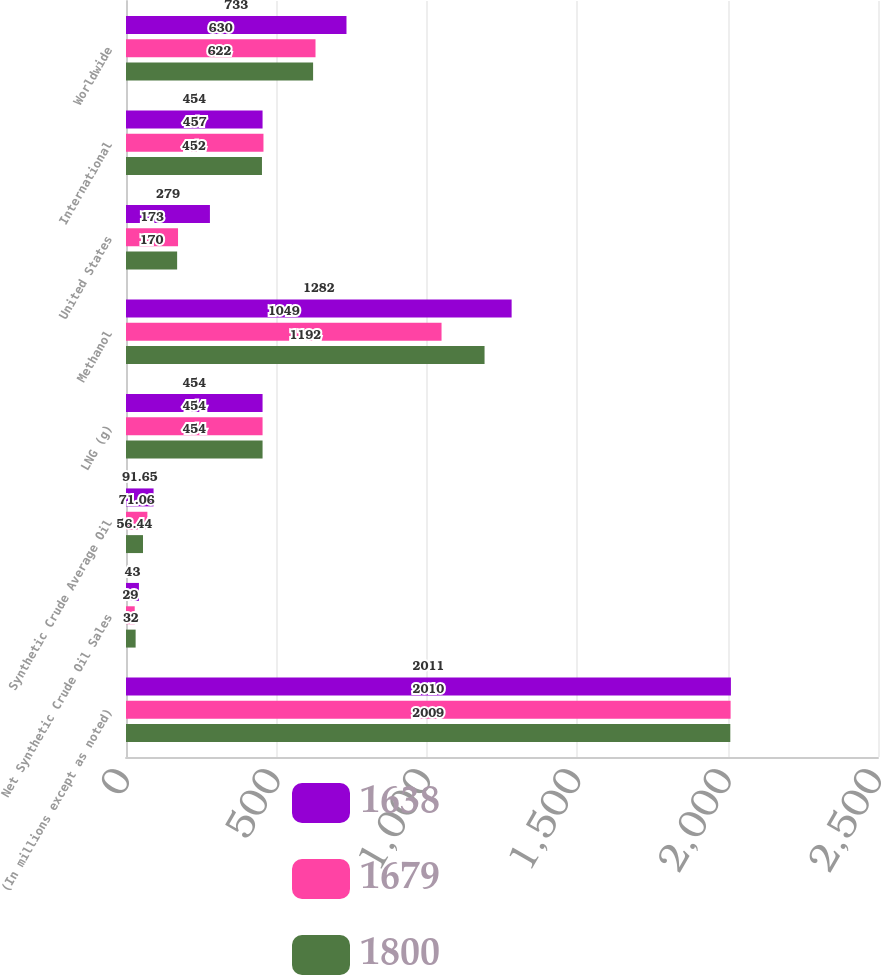<chart> <loc_0><loc_0><loc_500><loc_500><stacked_bar_chart><ecel><fcel>(In millions except as noted)<fcel>Net Synthetic Crude Oil Sales<fcel>Synthetic Crude Average Oil<fcel>LNG (g)<fcel>Methanol<fcel>United States<fcel>International<fcel>Worldwide<nl><fcel>1638<fcel>2011<fcel>43<fcel>91.65<fcel>454<fcel>1282<fcel>279<fcel>454<fcel>733<nl><fcel>1679<fcel>2010<fcel>29<fcel>71.06<fcel>454<fcel>1049<fcel>173<fcel>457<fcel>630<nl><fcel>1800<fcel>2009<fcel>32<fcel>56.44<fcel>454<fcel>1192<fcel>170<fcel>452<fcel>622<nl></chart> 